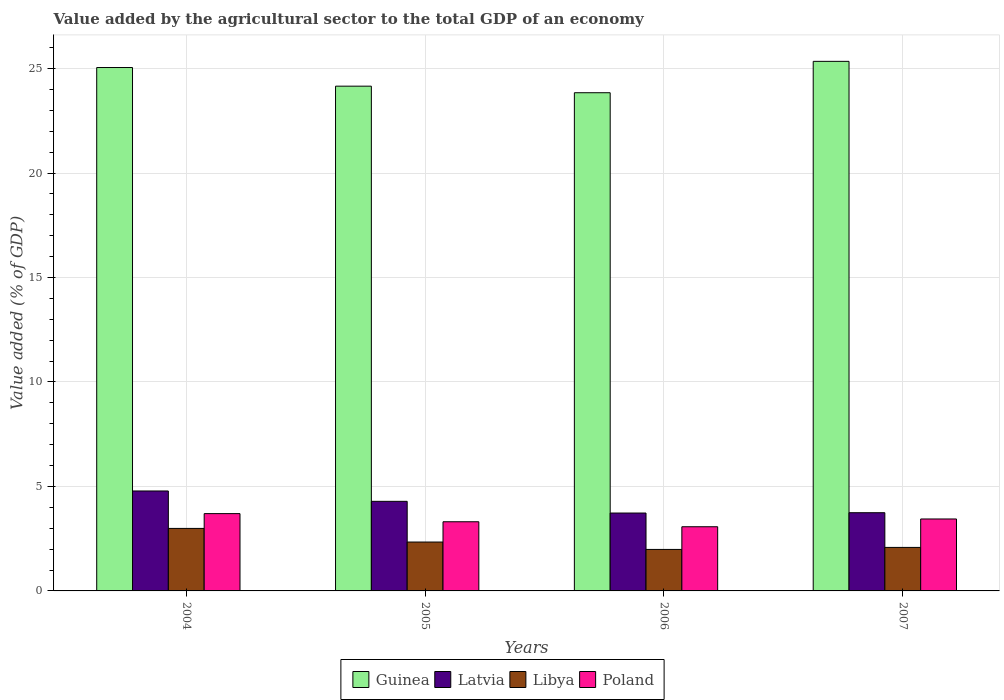How many different coloured bars are there?
Your response must be concise. 4. Are the number of bars per tick equal to the number of legend labels?
Your answer should be compact. Yes. How many bars are there on the 1st tick from the left?
Your answer should be compact. 4. How many bars are there on the 2nd tick from the right?
Ensure brevity in your answer.  4. What is the value added by the agricultural sector to the total GDP in Poland in 2004?
Make the answer very short. 3.7. Across all years, what is the maximum value added by the agricultural sector to the total GDP in Libya?
Provide a short and direct response. 2.99. Across all years, what is the minimum value added by the agricultural sector to the total GDP in Libya?
Provide a short and direct response. 1.99. In which year was the value added by the agricultural sector to the total GDP in Libya minimum?
Provide a succinct answer. 2006. What is the total value added by the agricultural sector to the total GDP in Libya in the graph?
Make the answer very short. 9.4. What is the difference between the value added by the agricultural sector to the total GDP in Guinea in 2005 and that in 2006?
Make the answer very short. 0.31. What is the difference between the value added by the agricultural sector to the total GDP in Latvia in 2005 and the value added by the agricultural sector to the total GDP in Guinea in 2004?
Provide a short and direct response. -20.76. What is the average value added by the agricultural sector to the total GDP in Guinea per year?
Keep it short and to the point. 24.6. In the year 2006, what is the difference between the value added by the agricultural sector to the total GDP in Poland and value added by the agricultural sector to the total GDP in Latvia?
Offer a terse response. -0.66. In how many years, is the value added by the agricultural sector to the total GDP in Poland greater than 25 %?
Give a very brief answer. 0. What is the ratio of the value added by the agricultural sector to the total GDP in Poland in 2005 to that in 2006?
Provide a succinct answer. 1.08. Is the value added by the agricultural sector to the total GDP in Guinea in 2005 less than that in 2007?
Offer a very short reply. Yes. Is the difference between the value added by the agricultural sector to the total GDP in Poland in 2004 and 2006 greater than the difference between the value added by the agricultural sector to the total GDP in Latvia in 2004 and 2006?
Provide a succinct answer. No. What is the difference between the highest and the second highest value added by the agricultural sector to the total GDP in Latvia?
Offer a very short reply. 0.5. What is the difference between the highest and the lowest value added by the agricultural sector to the total GDP in Poland?
Your answer should be compact. 0.63. What does the 3rd bar from the left in 2005 represents?
Your answer should be compact. Libya. What does the 2nd bar from the right in 2007 represents?
Ensure brevity in your answer.  Libya. Are all the bars in the graph horizontal?
Your answer should be compact. No. Are the values on the major ticks of Y-axis written in scientific E-notation?
Give a very brief answer. No. Does the graph contain any zero values?
Make the answer very short. No. Where does the legend appear in the graph?
Give a very brief answer. Bottom center. How are the legend labels stacked?
Give a very brief answer. Horizontal. What is the title of the graph?
Give a very brief answer. Value added by the agricultural sector to the total GDP of an economy. What is the label or title of the Y-axis?
Keep it short and to the point. Value added (% of GDP). What is the Value added (% of GDP) in Guinea in 2004?
Keep it short and to the point. 25.05. What is the Value added (% of GDP) in Latvia in 2004?
Offer a very short reply. 4.78. What is the Value added (% of GDP) in Libya in 2004?
Your answer should be compact. 2.99. What is the Value added (% of GDP) in Poland in 2004?
Your answer should be very brief. 3.7. What is the Value added (% of GDP) of Guinea in 2005?
Give a very brief answer. 24.16. What is the Value added (% of GDP) in Latvia in 2005?
Provide a succinct answer. 4.29. What is the Value added (% of GDP) of Libya in 2005?
Your answer should be compact. 2.34. What is the Value added (% of GDP) in Poland in 2005?
Offer a very short reply. 3.31. What is the Value added (% of GDP) of Guinea in 2006?
Offer a terse response. 23.84. What is the Value added (% of GDP) of Latvia in 2006?
Your answer should be compact. 3.73. What is the Value added (% of GDP) of Libya in 2006?
Offer a very short reply. 1.99. What is the Value added (% of GDP) in Poland in 2006?
Offer a very short reply. 3.07. What is the Value added (% of GDP) in Guinea in 2007?
Your response must be concise. 25.35. What is the Value added (% of GDP) in Latvia in 2007?
Provide a succinct answer. 3.74. What is the Value added (% of GDP) of Libya in 2007?
Keep it short and to the point. 2.08. What is the Value added (% of GDP) of Poland in 2007?
Offer a terse response. 3.44. Across all years, what is the maximum Value added (% of GDP) of Guinea?
Your answer should be compact. 25.35. Across all years, what is the maximum Value added (% of GDP) in Latvia?
Your answer should be very brief. 4.78. Across all years, what is the maximum Value added (% of GDP) of Libya?
Provide a short and direct response. 2.99. Across all years, what is the maximum Value added (% of GDP) of Poland?
Offer a very short reply. 3.7. Across all years, what is the minimum Value added (% of GDP) in Guinea?
Offer a terse response. 23.84. Across all years, what is the minimum Value added (% of GDP) of Latvia?
Keep it short and to the point. 3.73. Across all years, what is the minimum Value added (% of GDP) in Libya?
Your answer should be very brief. 1.99. Across all years, what is the minimum Value added (% of GDP) in Poland?
Your answer should be compact. 3.07. What is the total Value added (% of GDP) in Guinea in the graph?
Provide a succinct answer. 98.4. What is the total Value added (% of GDP) of Latvia in the graph?
Ensure brevity in your answer.  16.54. What is the total Value added (% of GDP) of Poland in the graph?
Your answer should be compact. 13.52. What is the difference between the Value added (% of GDP) of Guinea in 2004 and that in 2005?
Your answer should be compact. 0.89. What is the difference between the Value added (% of GDP) of Latvia in 2004 and that in 2005?
Make the answer very short. 0.5. What is the difference between the Value added (% of GDP) of Libya in 2004 and that in 2005?
Offer a very short reply. 0.65. What is the difference between the Value added (% of GDP) in Poland in 2004 and that in 2005?
Offer a very short reply. 0.39. What is the difference between the Value added (% of GDP) of Guinea in 2004 and that in 2006?
Keep it short and to the point. 1.21. What is the difference between the Value added (% of GDP) in Latvia in 2004 and that in 2006?
Make the answer very short. 1.06. What is the difference between the Value added (% of GDP) in Libya in 2004 and that in 2006?
Provide a succinct answer. 1.01. What is the difference between the Value added (% of GDP) in Poland in 2004 and that in 2006?
Your answer should be compact. 0.63. What is the difference between the Value added (% of GDP) in Guinea in 2004 and that in 2007?
Give a very brief answer. -0.3. What is the difference between the Value added (% of GDP) of Latvia in 2004 and that in 2007?
Keep it short and to the point. 1.04. What is the difference between the Value added (% of GDP) in Libya in 2004 and that in 2007?
Make the answer very short. 0.91. What is the difference between the Value added (% of GDP) in Poland in 2004 and that in 2007?
Provide a short and direct response. 0.26. What is the difference between the Value added (% of GDP) of Guinea in 2005 and that in 2006?
Your answer should be compact. 0.31. What is the difference between the Value added (% of GDP) in Latvia in 2005 and that in 2006?
Ensure brevity in your answer.  0.56. What is the difference between the Value added (% of GDP) of Libya in 2005 and that in 2006?
Your answer should be compact. 0.35. What is the difference between the Value added (% of GDP) in Poland in 2005 and that in 2006?
Your answer should be compact. 0.24. What is the difference between the Value added (% of GDP) of Guinea in 2005 and that in 2007?
Offer a very short reply. -1.19. What is the difference between the Value added (% of GDP) of Latvia in 2005 and that in 2007?
Make the answer very short. 0.54. What is the difference between the Value added (% of GDP) in Libya in 2005 and that in 2007?
Provide a succinct answer. 0.26. What is the difference between the Value added (% of GDP) in Poland in 2005 and that in 2007?
Offer a terse response. -0.13. What is the difference between the Value added (% of GDP) in Guinea in 2006 and that in 2007?
Offer a very short reply. -1.5. What is the difference between the Value added (% of GDP) in Latvia in 2006 and that in 2007?
Your answer should be compact. -0.02. What is the difference between the Value added (% of GDP) of Libya in 2006 and that in 2007?
Provide a short and direct response. -0.1. What is the difference between the Value added (% of GDP) of Poland in 2006 and that in 2007?
Offer a very short reply. -0.37. What is the difference between the Value added (% of GDP) of Guinea in 2004 and the Value added (% of GDP) of Latvia in 2005?
Your answer should be very brief. 20.76. What is the difference between the Value added (% of GDP) in Guinea in 2004 and the Value added (% of GDP) in Libya in 2005?
Your answer should be very brief. 22.71. What is the difference between the Value added (% of GDP) in Guinea in 2004 and the Value added (% of GDP) in Poland in 2005?
Make the answer very short. 21.74. What is the difference between the Value added (% of GDP) of Latvia in 2004 and the Value added (% of GDP) of Libya in 2005?
Provide a short and direct response. 2.44. What is the difference between the Value added (% of GDP) in Latvia in 2004 and the Value added (% of GDP) in Poland in 2005?
Make the answer very short. 1.47. What is the difference between the Value added (% of GDP) in Libya in 2004 and the Value added (% of GDP) in Poland in 2005?
Provide a short and direct response. -0.32. What is the difference between the Value added (% of GDP) in Guinea in 2004 and the Value added (% of GDP) in Latvia in 2006?
Give a very brief answer. 21.32. What is the difference between the Value added (% of GDP) of Guinea in 2004 and the Value added (% of GDP) of Libya in 2006?
Keep it short and to the point. 23.06. What is the difference between the Value added (% of GDP) in Guinea in 2004 and the Value added (% of GDP) in Poland in 2006?
Keep it short and to the point. 21.98. What is the difference between the Value added (% of GDP) of Latvia in 2004 and the Value added (% of GDP) of Libya in 2006?
Offer a very short reply. 2.8. What is the difference between the Value added (% of GDP) of Latvia in 2004 and the Value added (% of GDP) of Poland in 2006?
Ensure brevity in your answer.  1.71. What is the difference between the Value added (% of GDP) of Libya in 2004 and the Value added (% of GDP) of Poland in 2006?
Ensure brevity in your answer.  -0.08. What is the difference between the Value added (% of GDP) of Guinea in 2004 and the Value added (% of GDP) of Latvia in 2007?
Your answer should be compact. 21.31. What is the difference between the Value added (% of GDP) of Guinea in 2004 and the Value added (% of GDP) of Libya in 2007?
Ensure brevity in your answer.  22.97. What is the difference between the Value added (% of GDP) in Guinea in 2004 and the Value added (% of GDP) in Poland in 2007?
Keep it short and to the point. 21.61. What is the difference between the Value added (% of GDP) in Latvia in 2004 and the Value added (% of GDP) in Libya in 2007?
Your answer should be compact. 2.7. What is the difference between the Value added (% of GDP) in Latvia in 2004 and the Value added (% of GDP) in Poland in 2007?
Offer a very short reply. 1.34. What is the difference between the Value added (% of GDP) in Libya in 2004 and the Value added (% of GDP) in Poland in 2007?
Ensure brevity in your answer.  -0.45. What is the difference between the Value added (% of GDP) in Guinea in 2005 and the Value added (% of GDP) in Latvia in 2006?
Provide a short and direct response. 20.43. What is the difference between the Value added (% of GDP) of Guinea in 2005 and the Value added (% of GDP) of Libya in 2006?
Provide a succinct answer. 22.17. What is the difference between the Value added (% of GDP) of Guinea in 2005 and the Value added (% of GDP) of Poland in 2006?
Your response must be concise. 21.09. What is the difference between the Value added (% of GDP) in Latvia in 2005 and the Value added (% of GDP) in Libya in 2006?
Your answer should be very brief. 2.3. What is the difference between the Value added (% of GDP) in Latvia in 2005 and the Value added (% of GDP) in Poland in 2006?
Provide a succinct answer. 1.22. What is the difference between the Value added (% of GDP) in Libya in 2005 and the Value added (% of GDP) in Poland in 2006?
Your response must be concise. -0.73. What is the difference between the Value added (% of GDP) of Guinea in 2005 and the Value added (% of GDP) of Latvia in 2007?
Make the answer very short. 20.41. What is the difference between the Value added (% of GDP) in Guinea in 2005 and the Value added (% of GDP) in Libya in 2007?
Give a very brief answer. 22.08. What is the difference between the Value added (% of GDP) of Guinea in 2005 and the Value added (% of GDP) of Poland in 2007?
Provide a short and direct response. 20.71. What is the difference between the Value added (% of GDP) of Latvia in 2005 and the Value added (% of GDP) of Libya in 2007?
Provide a short and direct response. 2.2. What is the difference between the Value added (% of GDP) in Latvia in 2005 and the Value added (% of GDP) in Poland in 2007?
Keep it short and to the point. 0.84. What is the difference between the Value added (% of GDP) in Libya in 2005 and the Value added (% of GDP) in Poland in 2007?
Provide a succinct answer. -1.1. What is the difference between the Value added (% of GDP) of Guinea in 2006 and the Value added (% of GDP) of Latvia in 2007?
Give a very brief answer. 20.1. What is the difference between the Value added (% of GDP) of Guinea in 2006 and the Value added (% of GDP) of Libya in 2007?
Provide a succinct answer. 21.76. What is the difference between the Value added (% of GDP) of Guinea in 2006 and the Value added (% of GDP) of Poland in 2007?
Your answer should be compact. 20.4. What is the difference between the Value added (% of GDP) in Latvia in 2006 and the Value added (% of GDP) in Libya in 2007?
Offer a very short reply. 1.65. What is the difference between the Value added (% of GDP) in Latvia in 2006 and the Value added (% of GDP) in Poland in 2007?
Offer a terse response. 0.28. What is the difference between the Value added (% of GDP) in Libya in 2006 and the Value added (% of GDP) in Poland in 2007?
Your answer should be very brief. -1.46. What is the average Value added (% of GDP) in Guinea per year?
Provide a short and direct response. 24.6. What is the average Value added (% of GDP) of Latvia per year?
Offer a terse response. 4.14. What is the average Value added (% of GDP) in Libya per year?
Offer a terse response. 2.35. What is the average Value added (% of GDP) of Poland per year?
Make the answer very short. 3.38. In the year 2004, what is the difference between the Value added (% of GDP) in Guinea and Value added (% of GDP) in Latvia?
Give a very brief answer. 20.27. In the year 2004, what is the difference between the Value added (% of GDP) in Guinea and Value added (% of GDP) in Libya?
Offer a very short reply. 22.06. In the year 2004, what is the difference between the Value added (% of GDP) in Guinea and Value added (% of GDP) in Poland?
Offer a very short reply. 21.35. In the year 2004, what is the difference between the Value added (% of GDP) of Latvia and Value added (% of GDP) of Libya?
Provide a short and direct response. 1.79. In the year 2004, what is the difference between the Value added (% of GDP) in Latvia and Value added (% of GDP) in Poland?
Provide a succinct answer. 1.08. In the year 2004, what is the difference between the Value added (% of GDP) of Libya and Value added (% of GDP) of Poland?
Offer a terse response. -0.71. In the year 2005, what is the difference between the Value added (% of GDP) in Guinea and Value added (% of GDP) in Latvia?
Your answer should be very brief. 19.87. In the year 2005, what is the difference between the Value added (% of GDP) in Guinea and Value added (% of GDP) in Libya?
Ensure brevity in your answer.  21.82. In the year 2005, what is the difference between the Value added (% of GDP) in Guinea and Value added (% of GDP) in Poland?
Provide a succinct answer. 20.85. In the year 2005, what is the difference between the Value added (% of GDP) of Latvia and Value added (% of GDP) of Libya?
Your response must be concise. 1.95. In the year 2005, what is the difference between the Value added (% of GDP) in Latvia and Value added (% of GDP) in Poland?
Make the answer very short. 0.98. In the year 2005, what is the difference between the Value added (% of GDP) in Libya and Value added (% of GDP) in Poland?
Ensure brevity in your answer.  -0.97. In the year 2006, what is the difference between the Value added (% of GDP) of Guinea and Value added (% of GDP) of Latvia?
Your answer should be very brief. 20.12. In the year 2006, what is the difference between the Value added (% of GDP) in Guinea and Value added (% of GDP) in Libya?
Offer a terse response. 21.86. In the year 2006, what is the difference between the Value added (% of GDP) of Guinea and Value added (% of GDP) of Poland?
Give a very brief answer. 20.77. In the year 2006, what is the difference between the Value added (% of GDP) in Latvia and Value added (% of GDP) in Libya?
Provide a succinct answer. 1.74. In the year 2006, what is the difference between the Value added (% of GDP) of Latvia and Value added (% of GDP) of Poland?
Ensure brevity in your answer.  0.66. In the year 2006, what is the difference between the Value added (% of GDP) of Libya and Value added (% of GDP) of Poland?
Ensure brevity in your answer.  -1.09. In the year 2007, what is the difference between the Value added (% of GDP) in Guinea and Value added (% of GDP) in Latvia?
Give a very brief answer. 21.6. In the year 2007, what is the difference between the Value added (% of GDP) of Guinea and Value added (% of GDP) of Libya?
Your answer should be very brief. 23.26. In the year 2007, what is the difference between the Value added (% of GDP) of Guinea and Value added (% of GDP) of Poland?
Provide a succinct answer. 21.9. In the year 2007, what is the difference between the Value added (% of GDP) of Latvia and Value added (% of GDP) of Libya?
Your answer should be compact. 1.66. In the year 2007, what is the difference between the Value added (% of GDP) of Latvia and Value added (% of GDP) of Poland?
Offer a very short reply. 0.3. In the year 2007, what is the difference between the Value added (% of GDP) in Libya and Value added (% of GDP) in Poland?
Provide a short and direct response. -1.36. What is the ratio of the Value added (% of GDP) in Guinea in 2004 to that in 2005?
Offer a terse response. 1.04. What is the ratio of the Value added (% of GDP) of Latvia in 2004 to that in 2005?
Provide a short and direct response. 1.12. What is the ratio of the Value added (% of GDP) of Libya in 2004 to that in 2005?
Give a very brief answer. 1.28. What is the ratio of the Value added (% of GDP) of Poland in 2004 to that in 2005?
Your answer should be very brief. 1.12. What is the ratio of the Value added (% of GDP) of Guinea in 2004 to that in 2006?
Give a very brief answer. 1.05. What is the ratio of the Value added (% of GDP) of Latvia in 2004 to that in 2006?
Keep it short and to the point. 1.28. What is the ratio of the Value added (% of GDP) in Libya in 2004 to that in 2006?
Offer a very short reply. 1.51. What is the ratio of the Value added (% of GDP) in Poland in 2004 to that in 2006?
Your answer should be compact. 1.2. What is the ratio of the Value added (% of GDP) of Guinea in 2004 to that in 2007?
Keep it short and to the point. 0.99. What is the ratio of the Value added (% of GDP) in Latvia in 2004 to that in 2007?
Give a very brief answer. 1.28. What is the ratio of the Value added (% of GDP) in Libya in 2004 to that in 2007?
Offer a very short reply. 1.44. What is the ratio of the Value added (% of GDP) of Poland in 2004 to that in 2007?
Keep it short and to the point. 1.07. What is the ratio of the Value added (% of GDP) in Guinea in 2005 to that in 2006?
Give a very brief answer. 1.01. What is the ratio of the Value added (% of GDP) of Latvia in 2005 to that in 2006?
Provide a short and direct response. 1.15. What is the ratio of the Value added (% of GDP) of Libya in 2005 to that in 2006?
Offer a very short reply. 1.18. What is the ratio of the Value added (% of GDP) in Poland in 2005 to that in 2006?
Keep it short and to the point. 1.08. What is the ratio of the Value added (% of GDP) in Guinea in 2005 to that in 2007?
Keep it short and to the point. 0.95. What is the ratio of the Value added (% of GDP) of Latvia in 2005 to that in 2007?
Your answer should be compact. 1.15. What is the ratio of the Value added (% of GDP) in Libya in 2005 to that in 2007?
Your answer should be compact. 1.12. What is the ratio of the Value added (% of GDP) in Poland in 2005 to that in 2007?
Your response must be concise. 0.96. What is the ratio of the Value added (% of GDP) of Guinea in 2006 to that in 2007?
Keep it short and to the point. 0.94. What is the ratio of the Value added (% of GDP) of Libya in 2006 to that in 2007?
Offer a terse response. 0.95. What is the ratio of the Value added (% of GDP) of Poland in 2006 to that in 2007?
Provide a succinct answer. 0.89. What is the difference between the highest and the second highest Value added (% of GDP) in Guinea?
Your answer should be compact. 0.3. What is the difference between the highest and the second highest Value added (% of GDP) of Latvia?
Provide a succinct answer. 0.5. What is the difference between the highest and the second highest Value added (% of GDP) of Libya?
Keep it short and to the point. 0.65. What is the difference between the highest and the second highest Value added (% of GDP) of Poland?
Keep it short and to the point. 0.26. What is the difference between the highest and the lowest Value added (% of GDP) in Guinea?
Offer a very short reply. 1.5. What is the difference between the highest and the lowest Value added (% of GDP) of Latvia?
Give a very brief answer. 1.06. What is the difference between the highest and the lowest Value added (% of GDP) of Libya?
Your answer should be compact. 1.01. What is the difference between the highest and the lowest Value added (% of GDP) of Poland?
Give a very brief answer. 0.63. 